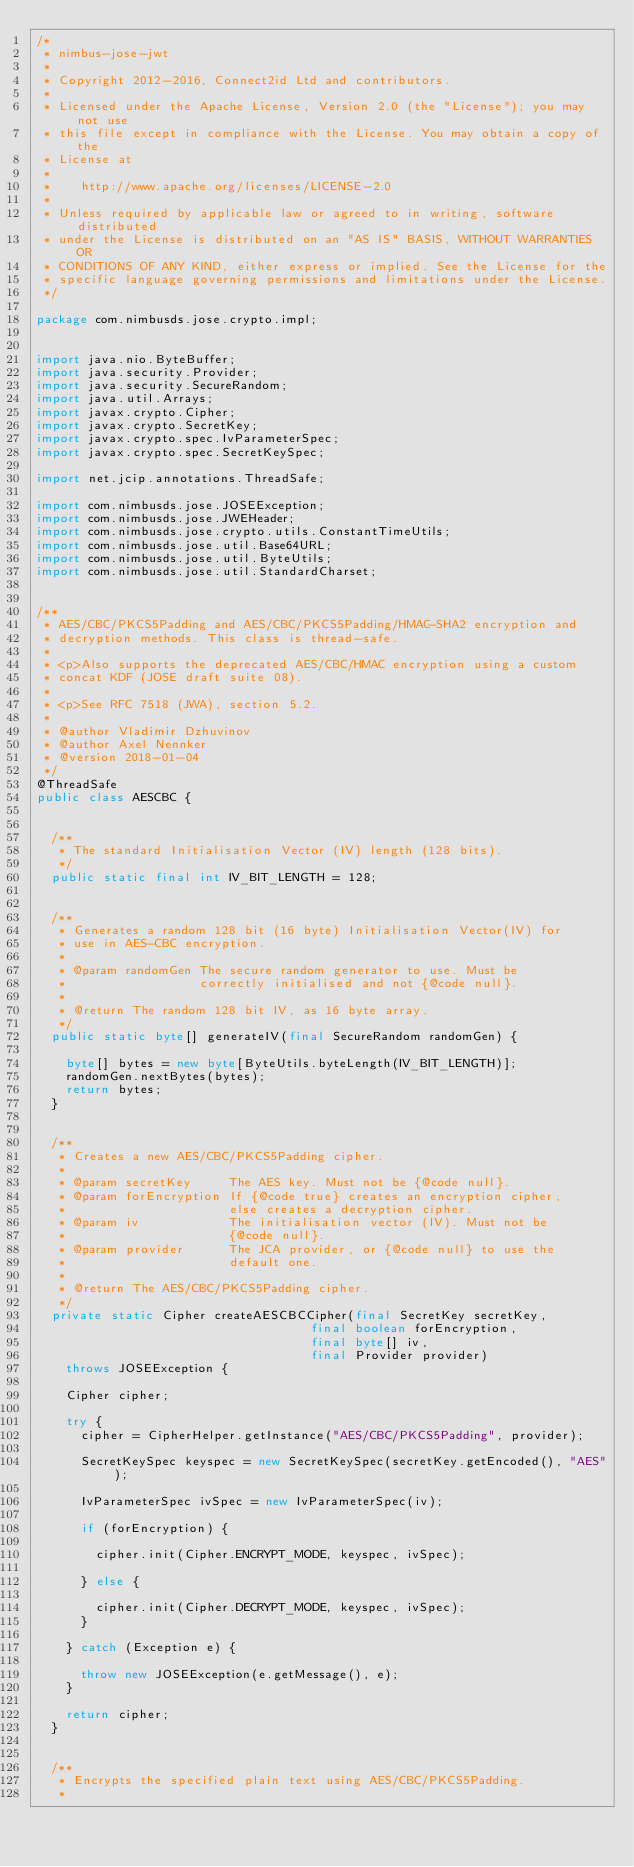Convert code to text. <code><loc_0><loc_0><loc_500><loc_500><_Java_>/*
 * nimbus-jose-jwt
 *
 * Copyright 2012-2016, Connect2id Ltd and contributors.
 *
 * Licensed under the Apache License, Version 2.0 (the "License"); you may not use
 * this file except in compliance with the License. You may obtain a copy of the
 * License at
 *
 *    http://www.apache.org/licenses/LICENSE-2.0
 *
 * Unless required by applicable law or agreed to in writing, software distributed
 * under the License is distributed on an "AS IS" BASIS, WITHOUT WARRANTIES OR
 * CONDITIONS OF ANY KIND, either express or implied. See the License for the
 * specific language governing permissions and limitations under the License.
 */

package com.nimbusds.jose.crypto.impl;


import java.nio.ByteBuffer;
import java.security.Provider;
import java.security.SecureRandom;
import java.util.Arrays;
import javax.crypto.Cipher;
import javax.crypto.SecretKey;
import javax.crypto.spec.IvParameterSpec;
import javax.crypto.spec.SecretKeySpec;

import net.jcip.annotations.ThreadSafe;

import com.nimbusds.jose.JOSEException;
import com.nimbusds.jose.JWEHeader;
import com.nimbusds.jose.crypto.utils.ConstantTimeUtils;
import com.nimbusds.jose.util.Base64URL;
import com.nimbusds.jose.util.ByteUtils;
import com.nimbusds.jose.util.StandardCharset;


/**
 * AES/CBC/PKCS5Padding and AES/CBC/PKCS5Padding/HMAC-SHA2 encryption and 
 * decryption methods. This class is thread-safe.
 *
 * <p>Also supports the deprecated AES/CBC/HMAC encryption using a custom
 * concat KDF (JOSE draft suite 08).
 *
 * <p>See RFC 7518 (JWA), section 5.2.
 *
 * @author Vladimir Dzhuvinov
 * @author Axel Nennker
 * @version 2018-01-04
 */
@ThreadSafe
public class AESCBC {


	/**
	 * The standard Initialisation Vector (IV) length (128 bits).
	 */
	public static final int IV_BIT_LENGTH = 128;


	/**
	 * Generates a random 128 bit (16 byte) Initialisation Vector(IV) for
	 * use in AES-CBC encryption.
	 *
	 * @param randomGen The secure random generator to use. Must be 
	 *                  correctly initialised and not {@code null}.
	 *
	 * @return The random 128 bit IV, as 16 byte array.
	 */
	public static byte[] generateIV(final SecureRandom randomGen) {
		
		byte[] bytes = new byte[ByteUtils.byteLength(IV_BIT_LENGTH)];
		randomGen.nextBytes(bytes);
		return bytes;
	}


	/**
	 * Creates a new AES/CBC/PKCS5Padding cipher.
	 *
	 * @param secretKey     The AES key. Must not be {@code null}.
	 * @param forEncryption If {@code true} creates an encryption cipher, 
	 *                      else creates a decryption cipher.
	 * @param iv            The initialisation vector (IV). Must not be
	 *                      {@code null}.
	 * @param provider      The JCA provider, or {@code null} to use the
	 *                      default one.
	 *
	 * @return The AES/CBC/PKCS5Padding cipher.
	 */
	private static Cipher createAESCBCCipher(final SecretKey secretKey,
		                                 final boolean forEncryption,
		                                 final byte[] iv,
		                                 final Provider provider)
		throws JOSEException {

		Cipher cipher;

		try {
			cipher = CipherHelper.getInstance("AES/CBC/PKCS5Padding", provider);

			SecretKeySpec keyspec = new SecretKeySpec(secretKey.getEncoded(), "AES");

			IvParameterSpec ivSpec = new IvParameterSpec(iv);

			if (forEncryption) {

				cipher.init(Cipher.ENCRYPT_MODE, keyspec, ivSpec);

			} else {

				cipher.init(Cipher.DECRYPT_MODE, keyspec, ivSpec);
			}

		} catch (Exception e) {

			throw new JOSEException(e.getMessage(), e);
		}

		return cipher;
	}


	/**
	 * Encrypts the specified plain text using AES/CBC/PKCS5Padding.
	 *</code> 